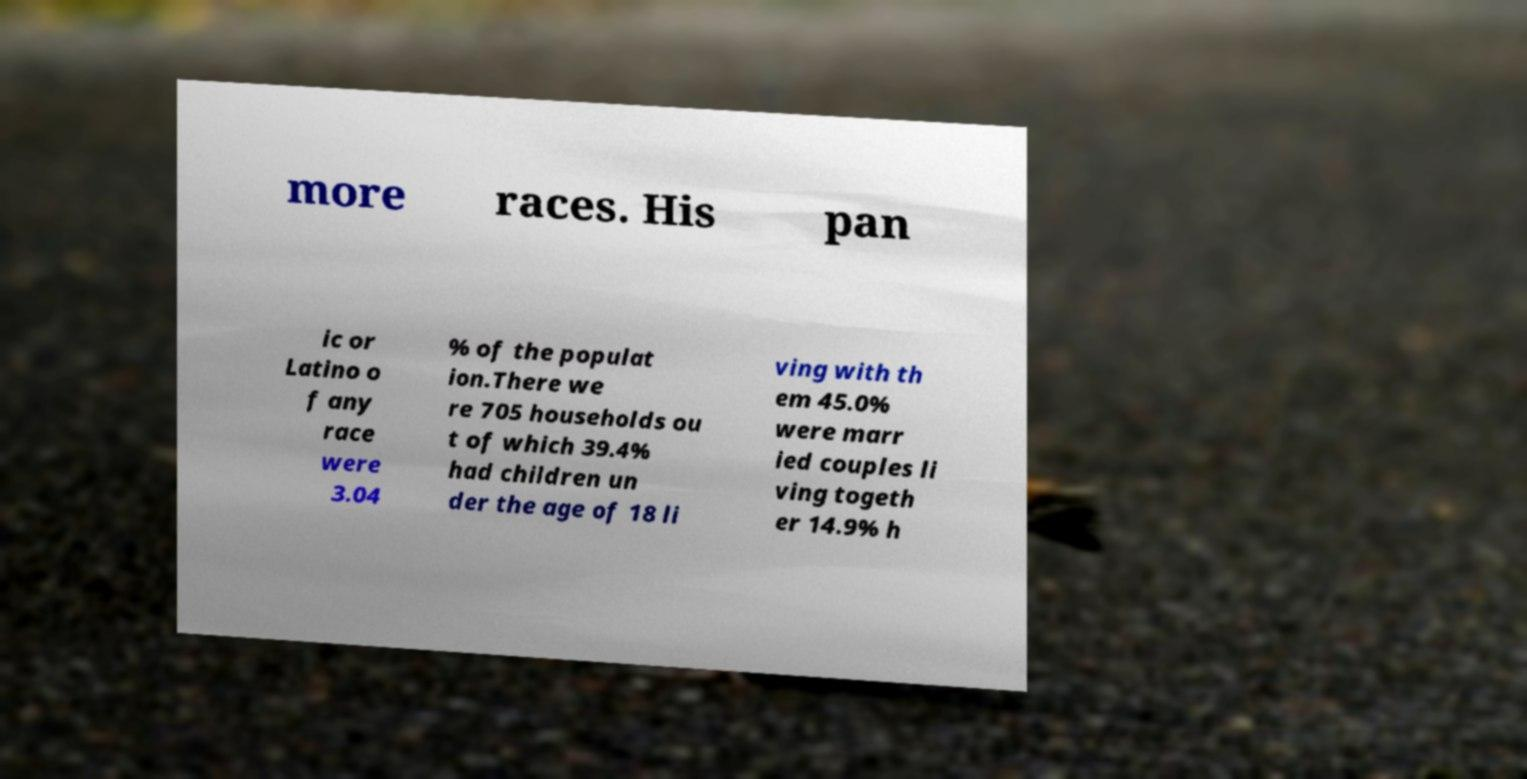I need the written content from this picture converted into text. Can you do that? more races. His pan ic or Latino o f any race were 3.04 % of the populat ion.There we re 705 households ou t of which 39.4% had children un der the age of 18 li ving with th em 45.0% were marr ied couples li ving togeth er 14.9% h 